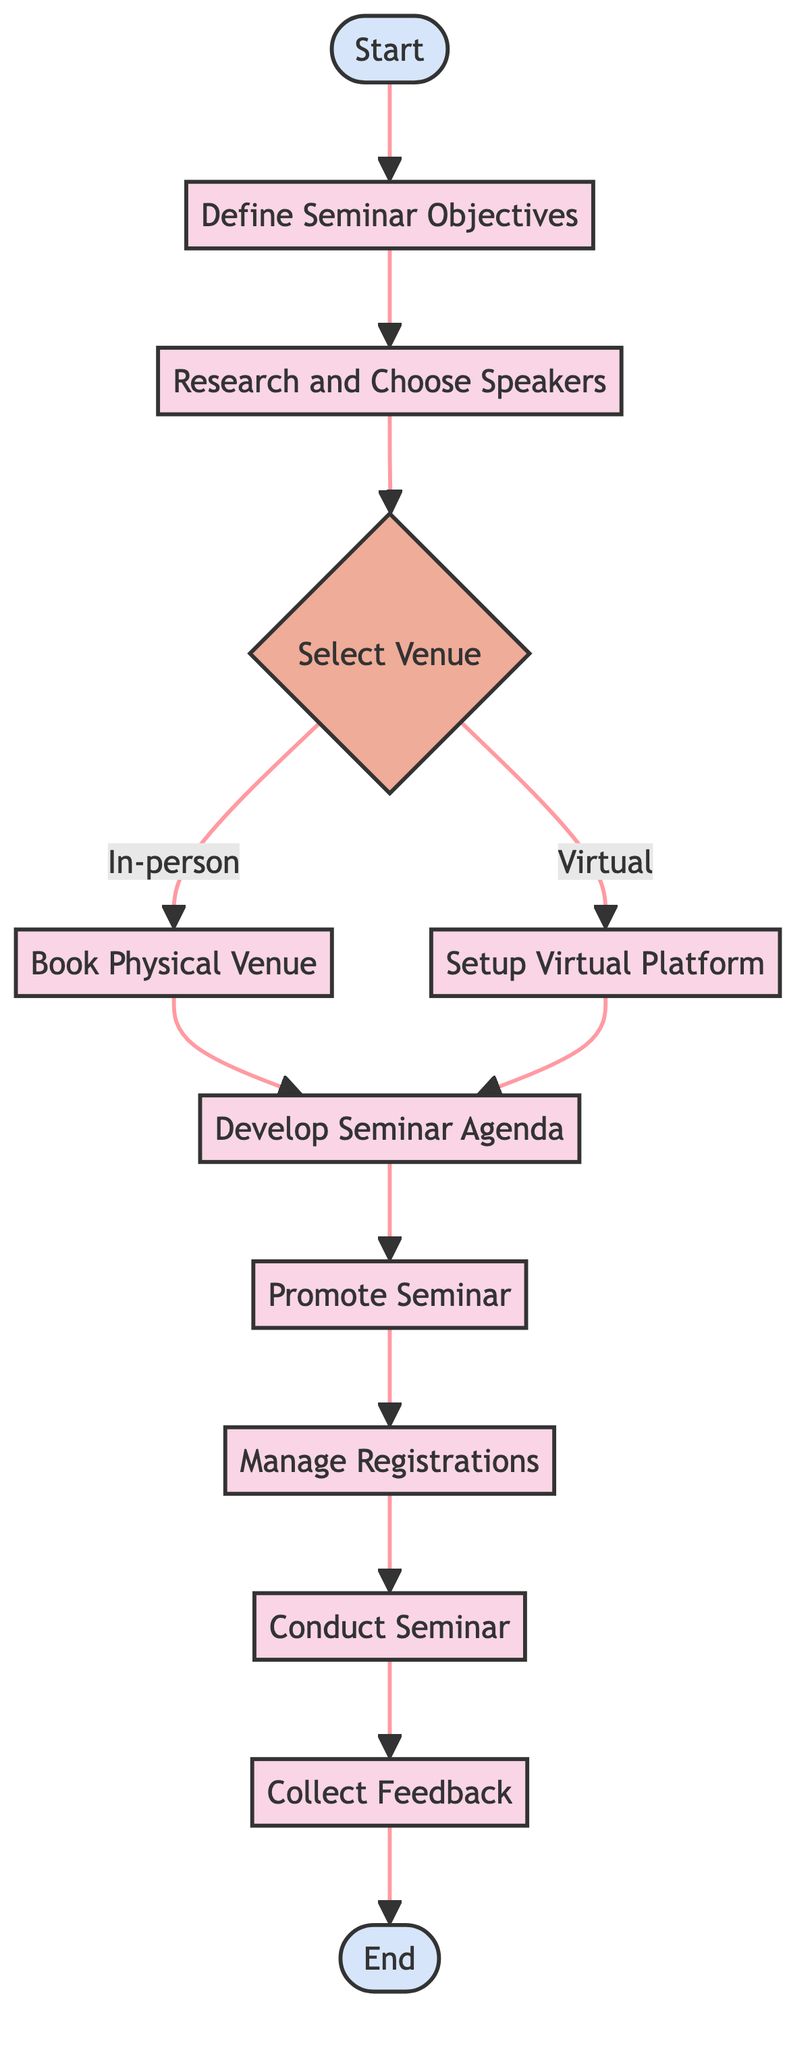What is the first step in the seminar organization process? The diagram indicates that the first step is labeled as "Start," denoting the beginning of the process.
Answer: Start How many decision nodes are present in the diagram? The diagram contains one decision node, which is the "Select Venue" element.
Answer: 1 What type of element is "Research and Choose Speakers"? The diagram shows that "Research and Choose Speakers" is categorized as a process type element.
Answer: process What follows after "Define Seminar Objectives"? According to the flowchart, "Define Seminar Objectives" is immediately followed by "Research and Choose Speakers."
Answer: Research and Choose Speakers If the venue selected is virtual, which step comes next? If "Select Venue" leads to "Virtual," the next step indicated in the diagram is "Setup Virtual Platform."
Answer: Setup Virtual Platform What is the final step of the seminar organization flow? The last step in the flowchart is labeled as "End," marking the conclusion of the seminar organization process.
Answer: End Which element comes before "Promote Seminar"? The element that comes directly before "Promote Seminar" in the flowchart is "Develop Seminar Agenda."
Answer: Develop Seminar Agenda How many total nodes are in the diagram? Counting all elements represented in the diagram, there are 12 nodes present in total.
Answer: 12 What action is taken after managing registrations? After "Manage Registrations," the next step outlined in the flowchart is "Conduct Seminar."
Answer: Conduct Seminar 